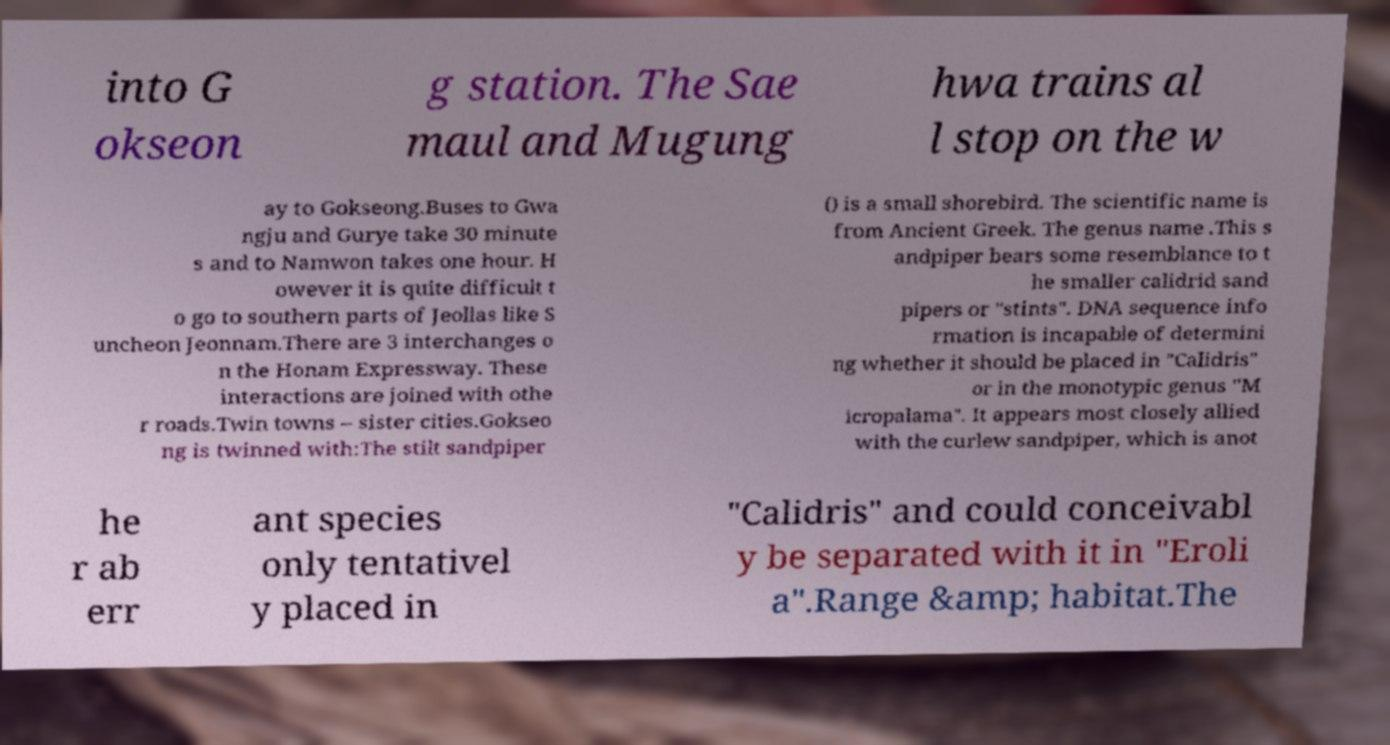Please read and relay the text visible in this image. What does it say? into G okseon g station. The Sae maul and Mugung hwa trains al l stop on the w ay to Gokseong.Buses to Gwa ngju and Gurye take 30 minute s and to Namwon takes one hour. H owever it is quite difficult t o go to southern parts of Jeollas like S uncheon Jeonnam.There are 3 interchanges o n the Honam Expressway. These interactions are joined with othe r roads.Twin towns – sister cities.Gokseo ng is twinned with:The stilt sandpiper () is a small shorebird. The scientific name is from Ancient Greek. The genus name .This s andpiper bears some resemblance to t he smaller calidrid sand pipers or "stints". DNA sequence info rmation is incapable of determini ng whether it should be placed in "Calidris" or in the monotypic genus "M icropalama". It appears most closely allied with the curlew sandpiper, which is anot he r ab err ant species only tentativel y placed in "Calidris" and could conceivabl y be separated with it in "Eroli a".Range &amp; habitat.The 